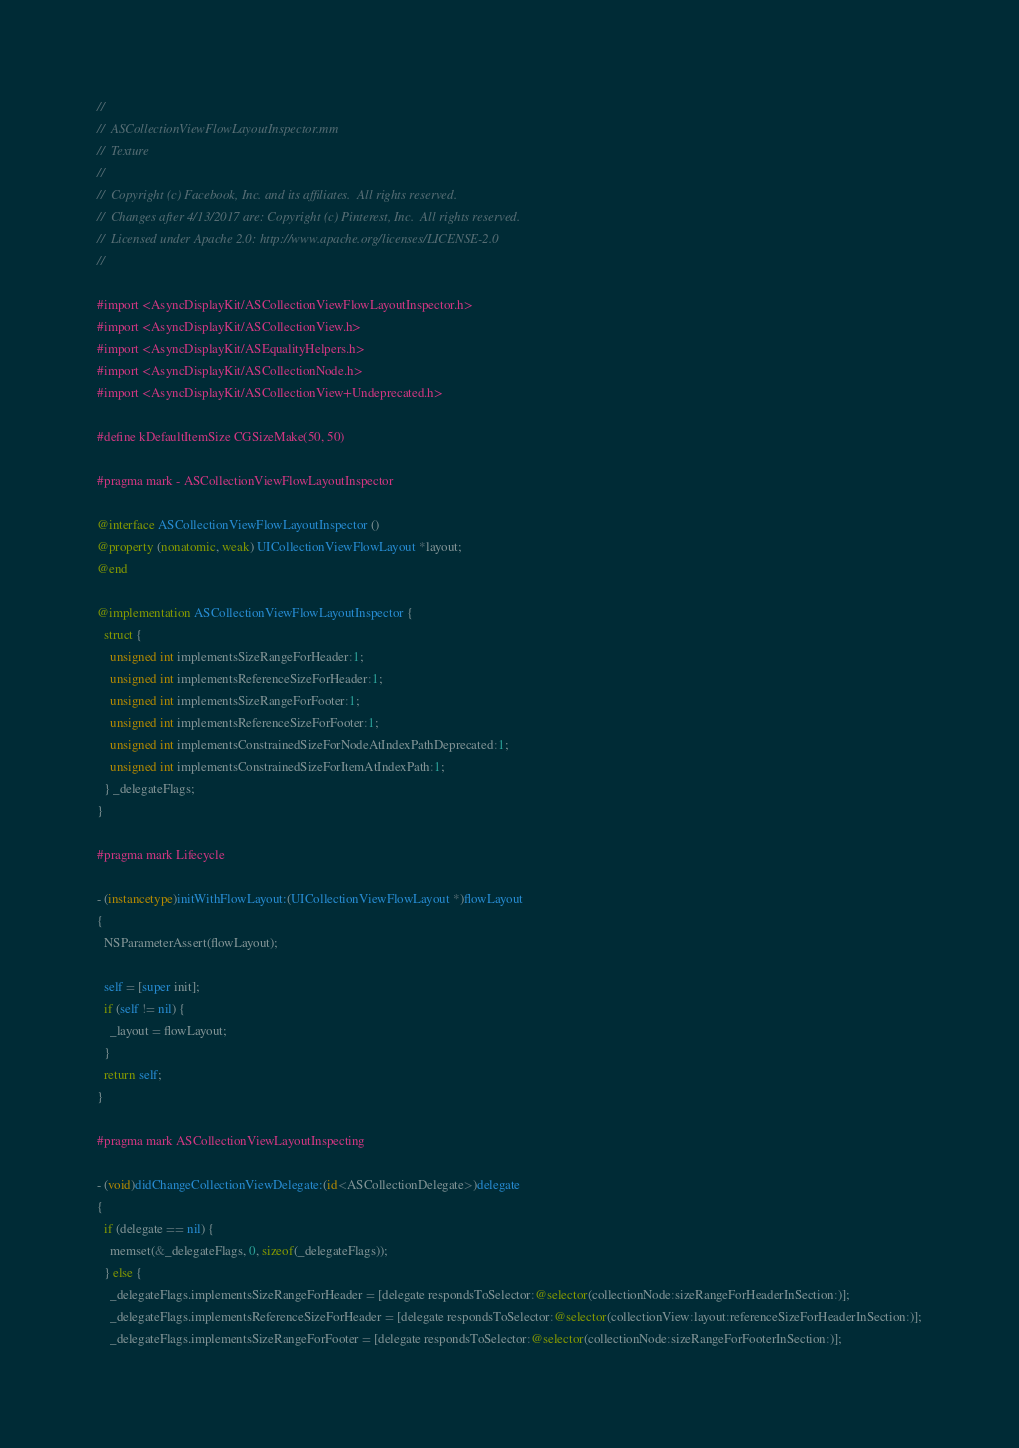<code> <loc_0><loc_0><loc_500><loc_500><_ObjectiveC_>//
//  ASCollectionViewFlowLayoutInspector.mm
//  Texture
//
//  Copyright (c) Facebook, Inc. and its affiliates.  All rights reserved.
//  Changes after 4/13/2017 are: Copyright (c) Pinterest, Inc.  All rights reserved.
//  Licensed under Apache 2.0: http://www.apache.org/licenses/LICENSE-2.0
//

#import <AsyncDisplayKit/ASCollectionViewFlowLayoutInspector.h>
#import <AsyncDisplayKit/ASCollectionView.h>
#import <AsyncDisplayKit/ASEqualityHelpers.h>
#import <AsyncDisplayKit/ASCollectionNode.h>
#import <AsyncDisplayKit/ASCollectionView+Undeprecated.h>

#define kDefaultItemSize CGSizeMake(50, 50)

#pragma mark - ASCollectionViewFlowLayoutInspector

@interface ASCollectionViewFlowLayoutInspector ()
@property (nonatomic, weak) UICollectionViewFlowLayout *layout;
@end
 
@implementation ASCollectionViewFlowLayoutInspector {
  struct {
    unsigned int implementsSizeRangeForHeader:1;
    unsigned int implementsReferenceSizeForHeader:1;
    unsigned int implementsSizeRangeForFooter:1;
    unsigned int implementsReferenceSizeForFooter:1;
    unsigned int implementsConstrainedSizeForNodeAtIndexPathDeprecated:1;
    unsigned int implementsConstrainedSizeForItemAtIndexPath:1;
  } _delegateFlags;
}

#pragma mark Lifecycle

- (instancetype)initWithFlowLayout:(UICollectionViewFlowLayout *)flowLayout
{
  NSParameterAssert(flowLayout);
  
  self = [super init];
  if (self != nil) {
    _layout = flowLayout;
  }
  return self;
}

#pragma mark ASCollectionViewLayoutInspecting

- (void)didChangeCollectionViewDelegate:(id<ASCollectionDelegate>)delegate
{
  if (delegate == nil) {
    memset(&_delegateFlags, 0, sizeof(_delegateFlags));
  } else {
    _delegateFlags.implementsSizeRangeForHeader = [delegate respondsToSelector:@selector(collectionNode:sizeRangeForHeaderInSection:)];
    _delegateFlags.implementsReferenceSizeForHeader = [delegate respondsToSelector:@selector(collectionView:layout:referenceSizeForHeaderInSection:)];
    _delegateFlags.implementsSizeRangeForFooter = [delegate respondsToSelector:@selector(collectionNode:sizeRangeForFooterInSection:)];</code> 